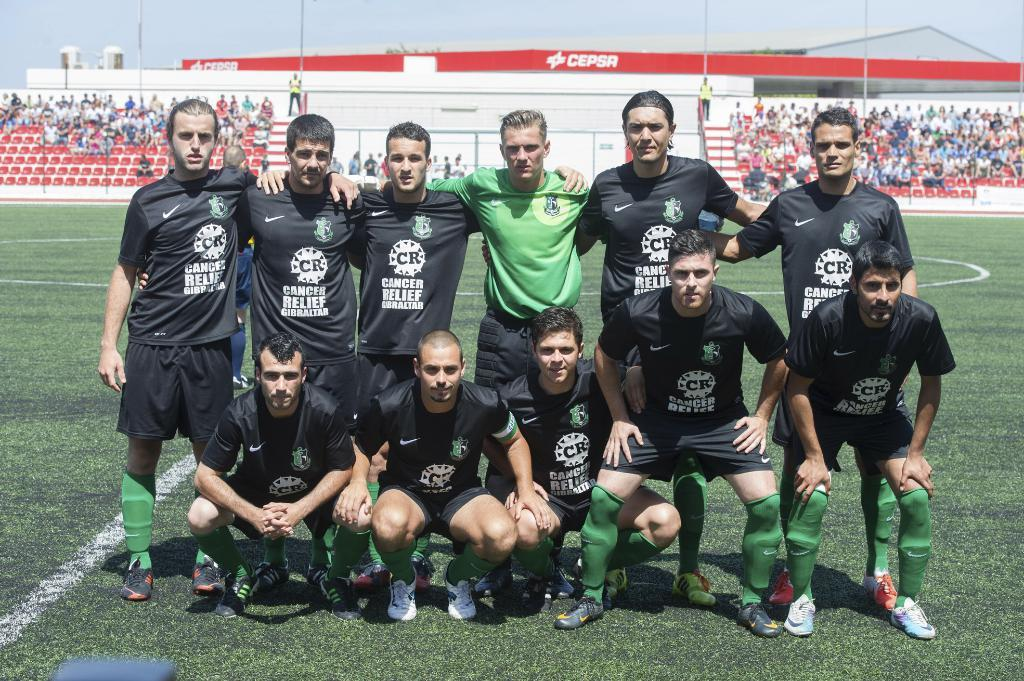<image>
Present a compact description of the photo's key features. Several soccer players wear jerseys that feature the phrase "cancer relief" 